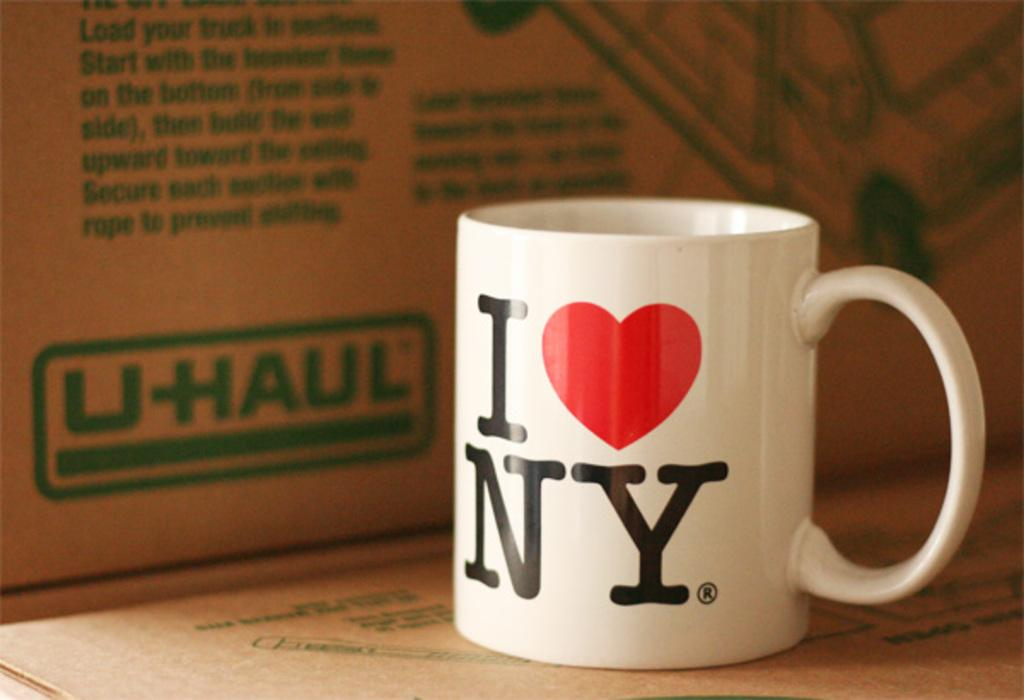<image>
Present a compact description of the photo's key features. A white mug with I heart NY on it next to a UHaul box. 